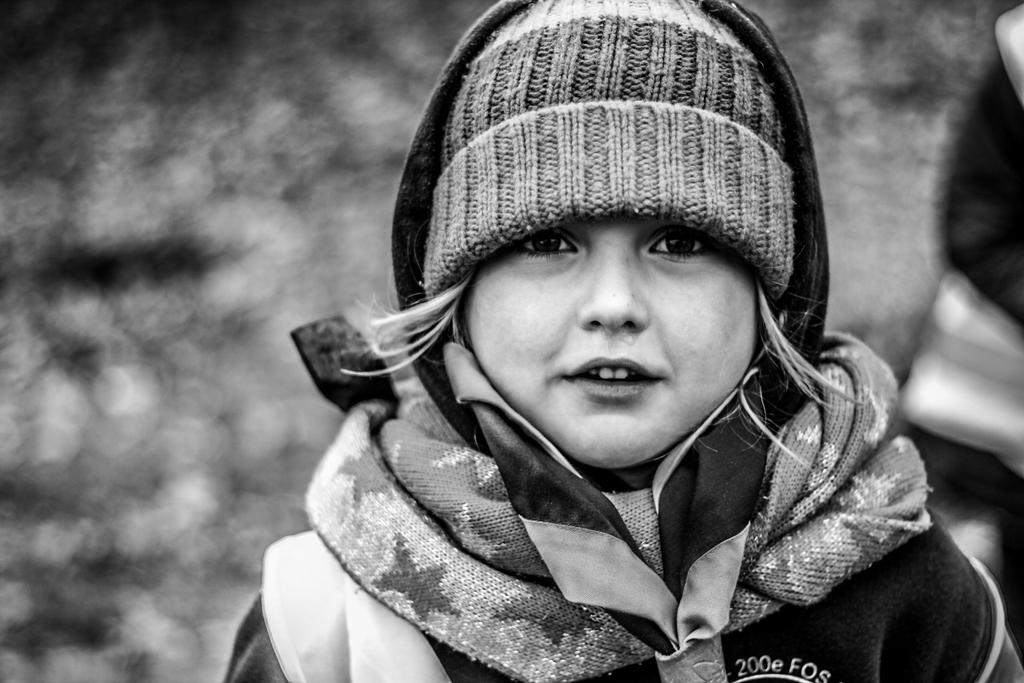Who is the main subject in the image? There is a girl in the image. What is the girl wearing on her head? The girl is wearing a woolen cap. What is the girl's posture in the image? The girl is standing. What can be seen on the ground in the image? There is an object on the ground in the image. How would you describe the background of the image? The background of the image is blurred. What type of bomb is the girl holding in the image? There is no bomb present in the image; the girl is wearing a woolen cap and standing. What color is the sheet draped over the girl in the image? There is no sheet present in the image; the girl is wearing a woolen cap and standing. 